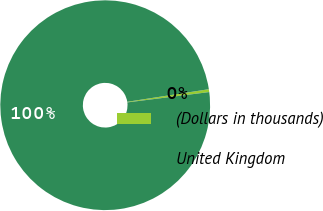Convert chart. <chart><loc_0><loc_0><loc_500><loc_500><pie_chart><fcel>(Dollars in thousands)<fcel>United Kingdom<nl><fcel>0.44%<fcel>99.56%<nl></chart> 